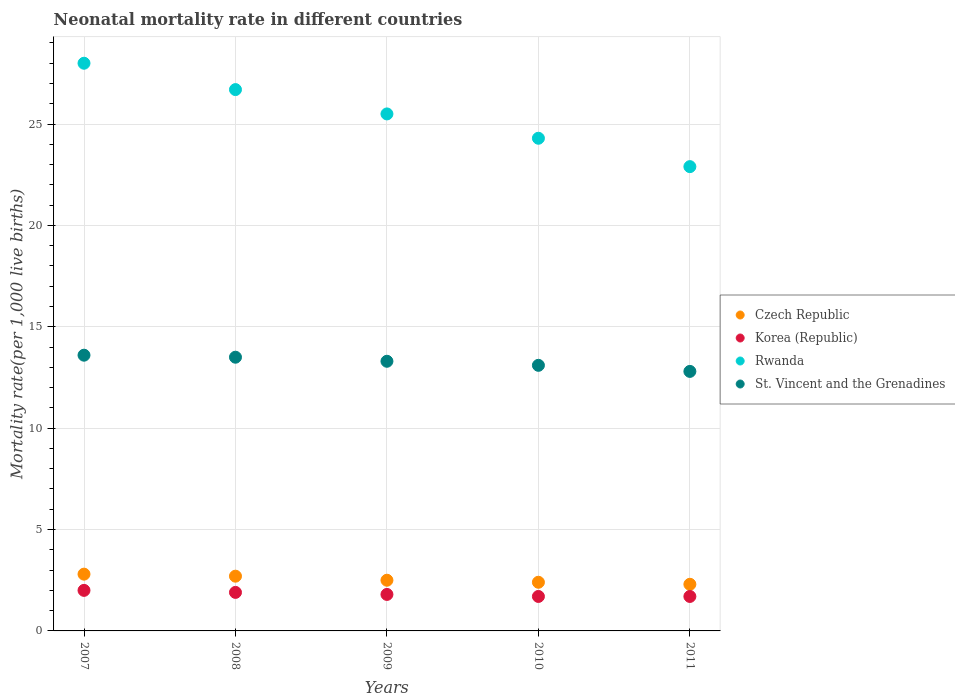How many different coloured dotlines are there?
Keep it short and to the point. 4. Across all years, what is the maximum neonatal mortality rate in Korea (Republic)?
Your response must be concise. 2. In which year was the neonatal mortality rate in St. Vincent and the Grenadines maximum?
Offer a very short reply. 2007. In which year was the neonatal mortality rate in Czech Republic minimum?
Offer a terse response. 2011. What is the total neonatal mortality rate in Czech Republic in the graph?
Provide a succinct answer. 12.7. What is the difference between the neonatal mortality rate in Rwanda in 2007 and that in 2010?
Your answer should be very brief. 3.7. What is the difference between the neonatal mortality rate in Czech Republic in 2009 and the neonatal mortality rate in Rwanda in 2007?
Give a very brief answer. -25.5. What is the average neonatal mortality rate in St. Vincent and the Grenadines per year?
Your response must be concise. 13.26. In how many years, is the neonatal mortality rate in Korea (Republic) greater than 23?
Make the answer very short. 0. What is the ratio of the neonatal mortality rate in Rwanda in 2008 to that in 2009?
Offer a very short reply. 1.05. Is the neonatal mortality rate in Korea (Republic) in 2009 less than that in 2010?
Provide a short and direct response. No. Is the difference between the neonatal mortality rate in Czech Republic in 2007 and 2008 greater than the difference between the neonatal mortality rate in Korea (Republic) in 2007 and 2008?
Your response must be concise. No. What is the difference between the highest and the second highest neonatal mortality rate in Korea (Republic)?
Give a very brief answer. 0.1. What is the difference between the highest and the lowest neonatal mortality rate in St. Vincent and the Grenadines?
Ensure brevity in your answer.  0.8. Is it the case that in every year, the sum of the neonatal mortality rate in Korea (Republic) and neonatal mortality rate in Rwanda  is greater than the sum of neonatal mortality rate in Czech Republic and neonatal mortality rate in St. Vincent and the Grenadines?
Provide a succinct answer. Yes. Is it the case that in every year, the sum of the neonatal mortality rate in Czech Republic and neonatal mortality rate in St. Vincent and the Grenadines  is greater than the neonatal mortality rate in Rwanda?
Ensure brevity in your answer.  No. Does the neonatal mortality rate in St. Vincent and the Grenadines monotonically increase over the years?
Make the answer very short. No. How many years are there in the graph?
Provide a short and direct response. 5. Does the graph contain grids?
Your answer should be compact. Yes. Where does the legend appear in the graph?
Your answer should be compact. Center right. What is the title of the graph?
Offer a very short reply. Neonatal mortality rate in different countries. What is the label or title of the Y-axis?
Offer a terse response. Mortality rate(per 1,0 live births). What is the Mortality rate(per 1,000 live births) in St. Vincent and the Grenadines in 2007?
Make the answer very short. 13.6. What is the Mortality rate(per 1,000 live births) of Korea (Republic) in 2008?
Ensure brevity in your answer.  1.9. What is the Mortality rate(per 1,000 live births) of Rwanda in 2008?
Keep it short and to the point. 26.7. What is the Mortality rate(per 1,000 live births) of St. Vincent and the Grenadines in 2008?
Provide a succinct answer. 13.5. What is the Mortality rate(per 1,000 live births) in Czech Republic in 2009?
Offer a terse response. 2.5. What is the Mortality rate(per 1,000 live births) of Rwanda in 2009?
Offer a terse response. 25.5. What is the Mortality rate(per 1,000 live births) in St. Vincent and the Grenadines in 2009?
Make the answer very short. 13.3. What is the Mortality rate(per 1,000 live births) of Czech Republic in 2010?
Provide a succinct answer. 2.4. What is the Mortality rate(per 1,000 live births) in Rwanda in 2010?
Keep it short and to the point. 24.3. What is the Mortality rate(per 1,000 live births) in St. Vincent and the Grenadines in 2010?
Make the answer very short. 13.1. What is the Mortality rate(per 1,000 live births) in Czech Republic in 2011?
Provide a short and direct response. 2.3. What is the Mortality rate(per 1,000 live births) of Korea (Republic) in 2011?
Your answer should be compact. 1.7. What is the Mortality rate(per 1,000 live births) of Rwanda in 2011?
Give a very brief answer. 22.9. Across all years, what is the maximum Mortality rate(per 1,000 live births) in Rwanda?
Provide a short and direct response. 28. Across all years, what is the minimum Mortality rate(per 1,000 live births) in Czech Republic?
Your response must be concise. 2.3. Across all years, what is the minimum Mortality rate(per 1,000 live births) of Korea (Republic)?
Your answer should be very brief. 1.7. Across all years, what is the minimum Mortality rate(per 1,000 live births) of Rwanda?
Keep it short and to the point. 22.9. Across all years, what is the minimum Mortality rate(per 1,000 live births) of St. Vincent and the Grenadines?
Give a very brief answer. 12.8. What is the total Mortality rate(per 1,000 live births) in Czech Republic in the graph?
Your answer should be very brief. 12.7. What is the total Mortality rate(per 1,000 live births) in Korea (Republic) in the graph?
Offer a terse response. 9.1. What is the total Mortality rate(per 1,000 live births) in Rwanda in the graph?
Your response must be concise. 127.4. What is the total Mortality rate(per 1,000 live births) of St. Vincent and the Grenadines in the graph?
Offer a very short reply. 66.3. What is the difference between the Mortality rate(per 1,000 live births) of Rwanda in 2007 and that in 2009?
Your response must be concise. 2.5. What is the difference between the Mortality rate(per 1,000 live births) of St. Vincent and the Grenadines in 2007 and that in 2009?
Keep it short and to the point. 0.3. What is the difference between the Mortality rate(per 1,000 live births) in Czech Republic in 2007 and that in 2010?
Your answer should be compact. 0.4. What is the difference between the Mortality rate(per 1,000 live births) in Czech Republic in 2007 and that in 2011?
Give a very brief answer. 0.5. What is the difference between the Mortality rate(per 1,000 live births) in St. Vincent and the Grenadines in 2007 and that in 2011?
Provide a short and direct response. 0.8. What is the difference between the Mortality rate(per 1,000 live births) in Czech Republic in 2008 and that in 2009?
Your answer should be very brief. 0.2. What is the difference between the Mortality rate(per 1,000 live births) of Korea (Republic) in 2008 and that in 2009?
Offer a terse response. 0.1. What is the difference between the Mortality rate(per 1,000 live births) in Rwanda in 2008 and that in 2009?
Your response must be concise. 1.2. What is the difference between the Mortality rate(per 1,000 live births) of St. Vincent and the Grenadines in 2008 and that in 2009?
Offer a terse response. 0.2. What is the difference between the Mortality rate(per 1,000 live births) in Korea (Republic) in 2008 and that in 2010?
Keep it short and to the point. 0.2. What is the difference between the Mortality rate(per 1,000 live births) in Rwanda in 2008 and that in 2010?
Your answer should be very brief. 2.4. What is the difference between the Mortality rate(per 1,000 live births) in St. Vincent and the Grenadines in 2008 and that in 2010?
Your answer should be very brief. 0.4. What is the difference between the Mortality rate(per 1,000 live births) of Czech Republic in 2008 and that in 2011?
Ensure brevity in your answer.  0.4. What is the difference between the Mortality rate(per 1,000 live births) of Korea (Republic) in 2008 and that in 2011?
Offer a terse response. 0.2. What is the difference between the Mortality rate(per 1,000 live births) of Rwanda in 2008 and that in 2011?
Make the answer very short. 3.8. What is the difference between the Mortality rate(per 1,000 live births) of St. Vincent and the Grenadines in 2008 and that in 2011?
Offer a terse response. 0.7. What is the difference between the Mortality rate(per 1,000 live births) of Czech Republic in 2009 and that in 2010?
Make the answer very short. 0.1. What is the difference between the Mortality rate(per 1,000 live births) of Korea (Republic) in 2009 and that in 2010?
Make the answer very short. 0.1. What is the difference between the Mortality rate(per 1,000 live births) of Czech Republic in 2009 and that in 2011?
Provide a short and direct response. 0.2. What is the difference between the Mortality rate(per 1,000 live births) of Korea (Republic) in 2009 and that in 2011?
Your answer should be compact. 0.1. What is the difference between the Mortality rate(per 1,000 live births) of Rwanda in 2009 and that in 2011?
Offer a very short reply. 2.6. What is the difference between the Mortality rate(per 1,000 live births) in Korea (Republic) in 2010 and that in 2011?
Offer a very short reply. 0. What is the difference between the Mortality rate(per 1,000 live births) of Rwanda in 2010 and that in 2011?
Give a very brief answer. 1.4. What is the difference between the Mortality rate(per 1,000 live births) in St. Vincent and the Grenadines in 2010 and that in 2011?
Your response must be concise. 0.3. What is the difference between the Mortality rate(per 1,000 live births) in Czech Republic in 2007 and the Mortality rate(per 1,000 live births) in Rwanda in 2008?
Ensure brevity in your answer.  -23.9. What is the difference between the Mortality rate(per 1,000 live births) in Czech Republic in 2007 and the Mortality rate(per 1,000 live births) in St. Vincent and the Grenadines in 2008?
Your response must be concise. -10.7. What is the difference between the Mortality rate(per 1,000 live births) in Korea (Republic) in 2007 and the Mortality rate(per 1,000 live births) in Rwanda in 2008?
Ensure brevity in your answer.  -24.7. What is the difference between the Mortality rate(per 1,000 live births) of Czech Republic in 2007 and the Mortality rate(per 1,000 live births) of Rwanda in 2009?
Your response must be concise. -22.7. What is the difference between the Mortality rate(per 1,000 live births) of Czech Republic in 2007 and the Mortality rate(per 1,000 live births) of St. Vincent and the Grenadines in 2009?
Provide a short and direct response. -10.5. What is the difference between the Mortality rate(per 1,000 live births) of Korea (Republic) in 2007 and the Mortality rate(per 1,000 live births) of Rwanda in 2009?
Offer a terse response. -23.5. What is the difference between the Mortality rate(per 1,000 live births) in Korea (Republic) in 2007 and the Mortality rate(per 1,000 live births) in St. Vincent and the Grenadines in 2009?
Give a very brief answer. -11.3. What is the difference between the Mortality rate(per 1,000 live births) in Czech Republic in 2007 and the Mortality rate(per 1,000 live births) in Rwanda in 2010?
Give a very brief answer. -21.5. What is the difference between the Mortality rate(per 1,000 live births) of Korea (Republic) in 2007 and the Mortality rate(per 1,000 live births) of Rwanda in 2010?
Provide a short and direct response. -22.3. What is the difference between the Mortality rate(per 1,000 live births) in Rwanda in 2007 and the Mortality rate(per 1,000 live births) in St. Vincent and the Grenadines in 2010?
Make the answer very short. 14.9. What is the difference between the Mortality rate(per 1,000 live births) of Czech Republic in 2007 and the Mortality rate(per 1,000 live births) of Rwanda in 2011?
Provide a succinct answer. -20.1. What is the difference between the Mortality rate(per 1,000 live births) in Korea (Republic) in 2007 and the Mortality rate(per 1,000 live births) in Rwanda in 2011?
Make the answer very short. -20.9. What is the difference between the Mortality rate(per 1,000 live births) in Korea (Republic) in 2007 and the Mortality rate(per 1,000 live births) in St. Vincent and the Grenadines in 2011?
Offer a terse response. -10.8. What is the difference between the Mortality rate(per 1,000 live births) of Czech Republic in 2008 and the Mortality rate(per 1,000 live births) of Korea (Republic) in 2009?
Your response must be concise. 0.9. What is the difference between the Mortality rate(per 1,000 live births) of Czech Republic in 2008 and the Mortality rate(per 1,000 live births) of Rwanda in 2009?
Make the answer very short. -22.8. What is the difference between the Mortality rate(per 1,000 live births) in Czech Republic in 2008 and the Mortality rate(per 1,000 live births) in St. Vincent and the Grenadines in 2009?
Give a very brief answer. -10.6. What is the difference between the Mortality rate(per 1,000 live births) of Korea (Republic) in 2008 and the Mortality rate(per 1,000 live births) of Rwanda in 2009?
Provide a short and direct response. -23.6. What is the difference between the Mortality rate(per 1,000 live births) in Czech Republic in 2008 and the Mortality rate(per 1,000 live births) in Rwanda in 2010?
Give a very brief answer. -21.6. What is the difference between the Mortality rate(per 1,000 live births) of Czech Republic in 2008 and the Mortality rate(per 1,000 live births) of St. Vincent and the Grenadines in 2010?
Your answer should be compact. -10.4. What is the difference between the Mortality rate(per 1,000 live births) of Korea (Republic) in 2008 and the Mortality rate(per 1,000 live births) of Rwanda in 2010?
Give a very brief answer. -22.4. What is the difference between the Mortality rate(per 1,000 live births) in Rwanda in 2008 and the Mortality rate(per 1,000 live births) in St. Vincent and the Grenadines in 2010?
Keep it short and to the point. 13.6. What is the difference between the Mortality rate(per 1,000 live births) in Czech Republic in 2008 and the Mortality rate(per 1,000 live births) in Rwanda in 2011?
Provide a short and direct response. -20.2. What is the difference between the Mortality rate(per 1,000 live births) in Czech Republic in 2008 and the Mortality rate(per 1,000 live births) in St. Vincent and the Grenadines in 2011?
Your response must be concise. -10.1. What is the difference between the Mortality rate(per 1,000 live births) of Korea (Republic) in 2008 and the Mortality rate(per 1,000 live births) of Rwanda in 2011?
Provide a succinct answer. -21. What is the difference between the Mortality rate(per 1,000 live births) in Korea (Republic) in 2008 and the Mortality rate(per 1,000 live births) in St. Vincent and the Grenadines in 2011?
Offer a terse response. -10.9. What is the difference between the Mortality rate(per 1,000 live births) in Czech Republic in 2009 and the Mortality rate(per 1,000 live births) in Korea (Republic) in 2010?
Make the answer very short. 0.8. What is the difference between the Mortality rate(per 1,000 live births) of Czech Republic in 2009 and the Mortality rate(per 1,000 live births) of Rwanda in 2010?
Your response must be concise. -21.8. What is the difference between the Mortality rate(per 1,000 live births) of Korea (Republic) in 2009 and the Mortality rate(per 1,000 live births) of Rwanda in 2010?
Ensure brevity in your answer.  -22.5. What is the difference between the Mortality rate(per 1,000 live births) in Czech Republic in 2009 and the Mortality rate(per 1,000 live births) in Rwanda in 2011?
Make the answer very short. -20.4. What is the difference between the Mortality rate(per 1,000 live births) of Korea (Republic) in 2009 and the Mortality rate(per 1,000 live births) of Rwanda in 2011?
Give a very brief answer. -21.1. What is the difference between the Mortality rate(per 1,000 live births) of Korea (Republic) in 2009 and the Mortality rate(per 1,000 live births) of St. Vincent and the Grenadines in 2011?
Provide a short and direct response. -11. What is the difference between the Mortality rate(per 1,000 live births) of Czech Republic in 2010 and the Mortality rate(per 1,000 live births) of Rwanda in 2011?
Make the answer very short. -20.5. What is the difference between the Mortality rate(per 1,000 live births) in Korea (Republic) in 2010 and the Mortality rate(per 1,000 live births) in Rwanda in 2011?
Provide a short and direct response. -21.2. What is the average Mortality rate(per 1,000 live births) of Czech Republic per year?
Offer a very short reply. 2.54. What is the average Mortality rate(per 1,000 live births) in Korea (Republic) per year?
Offer a terse response. 1.82. What is the average Mortality rate(per 1,000 live births) in Rwanda per year?
Your response must be concise. 25.48. What is the average Mortality rate(per 1,000 live births) in St. Vincent and the Grenadines per year?
Your response must be concise. 13.26. In the year 2007, what is the difference between the Mortality rate(per 1,000 live births) of Czech Republic and Mortality rate(per 1,000 live births) of Rwanda?
Provide a short and direct response. -25.2. In the year 2007, what is the difference between the Mortality rate(per 1,000 live births) of Czech Republic and Mortality rate(per 1,000 live births) of St. Vincent and the Grenadines?
Make the answer very short. -10.8. In the year 2008, what is the difference between the Mortality rate(per 1,000 live births) of Czech Republic and Mortality rate(per 1,000 live births) of St. Vincent and the Grenadines?
Give a very brief answer. -10.8. In the year 2008, what is the difference between the Mortality rate(per 1,000 live births) in Korea (Republic) and Mortality rate(per 1,000 live births) in Rwanda?
Ensure brevity in your answer.  -24.8. In the year 2009, what is the difference between the Mortality rate(per 1,000 live births) in Czech Republic and Mortality rate(per 1,000 live births) in Korea (Republic)?
Your answer should be compact. 0.7. In the year 2009, what is the difference between the Mortality rate(per 1,000 live births) in Czech Republic and Mortality rate(per 1,000 live births) in St. Vincent and the Grenadines?
Keep it short and to the point. -10.8. In the year 2009, what is the difference between the Mortality rate(per 1,000 live births) in Korea (Republic) and Mortality rate(per 1,000 live births) in Rwanda?
Offer a terse response. -23.7. In the year 2010, what is the difference between the Mortality rate(per 1,000 live births) of Czech Republic and Mortality rate(per 1,000 live births) of Rwanda?
Offer a terse response. -21.9. In the year 2010, what is the difference between the Mortality rate(per 1,000 live births) of Czech Republic and Mortality rate(per 1,000 live births) of St. Vincent and the Grenadines?
Provide a short and direct response. -10.7. In the year 2010, what is the difference between the Mortality rate(per 1,000 live births) of Korea (Republic) and Mortality rate(per 1,000 live births) of Rwanda?
Provide a short and direct response. -22.6. In the year 2011, what is the difference between the Mortality rate(per 1,000 live births) of Czech Republic and Mortality rate(per 1,000 live births) of Rwanda?
Ensure brevity in your answer.  -20.6. In the year 2011, what is the difference between the Mortality rate(per 1,000 live births) in Korea (Republic) and Mortality rate(per 1,000 live births) in Rwanda?
Offer a terse response. -21.2. In the year 2011, what is the difference between the Mortality rate(per 1,000 live births) of Korea (Republic) and Mortality rate(per 1,000 live births) of St. Vincent and the Grenadines?
Your response must be concise. -11.1. What is the ratio of the Mortality rate(per 1,000 live births) of Czech Republic in 2007 to that in 2008?
Offer a very short reply. 1.04. What is the ratio of the Mortality rate(per 1,000 live births) in Korea (Republic) in 2007 to that in 2008?
Your answer should be compact. 1.05. What is the ratio of the Mortality rate(per 1,000 live births) of Rwanda in 2007 to that in 2008?
Give a very brief answer. 1.05. What is the ratio of the Mortality rate(per 1,000 live births) in St. Vincent and the Grenadines in 2007 to that in 2008?
Your answer should be very brief. 1.01. What is the ratio of the Mortality rate(per 1,000 live births) of Czech Republic in 2007 to that in 2009?
Ensure brevity in your answer.  1.12. What is the ratio of the Mortality rate(per 1,000 live births) in Korea (Republic) in 2007 to that in 2009?
Make the answer very short. 1.11. What is the ratio of the Mortality rate(per 1,000 live births) in Rwanda in 2007 to that in 2009?
Give a very brief answer. 1.1. What is the ratio of the Mortality rate(per 1,000 live births) in St. Vincent and the Grenadines in 2007 to that in 2009?
Your response must be concise. 1.02. What is the ratio of the Mortality rate(per 1,000 live births) of Czech Republic in 2007 to that in 2010?
Your answer should be compact. 1.17. What is the ratio of the Mortality rate(per 1,000 live births) of Korea (Republic) in 2007 to that in 2010?
Offer a very short reply. 1.18. What is the ratio of the Mortality rate(per 1,000 live births) in Rwanda in 2007 to that in 2010?
Make the answer very short. 1.15. What is the ratio of the Mortality rate(per 1,000 live births) of St. Vincent and the Grenadines in 2007 to that in 2010?
Ensure brevity in your answer.  1.04. What is the ratio of the Mortality rate(per 1,000 live births) of Czech Republic in 2007 to that in 2011?
Provide a succinct answer. 1.22. What is the ratio of the Mortality rate(per 1,000 live births) of Korea (Republic) in 2007 to that in 2011?
Your response must be concise. 1.18. What is the ratio of the Mortality rate(per 1,000 live births) in Rwanda in 2007 to that in 2011?
Provide a short and direct response. 1.22. What is the ratio of the Mortality rate(per 1,000 live births) of St. Vincent and the Grenadines in 2007 to that in 2011?
Keep it short and to the point. 1.06. What is the ratio of the Mortality rate(per 1,000 live births) in Czech Republic in 2008 to that in 2009?
Ensure brevity in your answer.  1.08. What is the ratio of the Mortality rate(per 1,000 live births) of Korea (Republic) in 2008 to that in 2009?
Ensure brevity in your answer.  1.06. What is the ratio of the Mortality rate(per 1,000 live births) in Rwanda in 2008 to that in 2009?
Offer a terse response. 1.05. What is the ratio of the Mortality rate(per 1,000 live births) in St. Vincent and the Grenadines in 2008 to that in 2009?
Provide a succinct answer. 1.01. What is the ratio of the Mortality rate(per 1,000 live births) of Korea (Republic) in 2008 to that in 2010?
Your response must be concise. 1.12. What is the ratio of the Mortality rate(per 1,000 live births) of Rwanda in 2008 to that in 2010?
Your response must be concise. 1.1. What is the ratio of the Mortality rate(per 1,000 live births) of St. Vincent and the Grenadines in 2008 to that in 2010?
Provide a succinct answer. 1.03. What is the ratio of the Mortality rate(per 1,000 live births) of Czech Republic in 2008 to that in 2011?
Provide a short and direct response. 1.17. What is the ratio of the Mortality rate(per 1,000 live births) in Korea (Republic) in 2008 to that in 2011?
Provide a short and direct response. 1.12. What is the ratio of the Mortality rate(per 1,000 live births) in Rwanda in 2008 to that in 2011?
Keep it short and to the point. 1.17. What is the ratio of the Mortality rate(per 1,000 live births) of St. Vincent and the Grenadines in 2008 to that in 2011?
Make the answer very short. 1.05. What is the ratio of the Mortality rate(per 1,000 live births) of Czech Republic in 2009 to that in 2010?
Ensure brevity in your answer.  1.04. What is the ratio of the Mortality rate(per 1,000 live births) of Korea (Republic) in 2009 to that in 2010?
Provide a short and direct response. 1.06. What is the ratio of the Mortality rate(per 1,000 live births) of Rwanda in 2009 to that in 2010?
Offer a very short reply. 1.05. What is the ratio of the Mortality rate(per 1,000 live births) in St. Vincent and the Grenadines in 2009 to that in 2010?
Your answer should be compact. 1.02. What is the ratio of the Mortality rate(per 1,000 live births) in Czech Republic in 2009 to that in 2011?
Offer a terse response. 1.09. What is the ratio of the Mortality rate(per 1,000 live births) of Korea (Republic) in 2009 to that in 2011?
Your answer should be compact. 1.06. What is the ratio of the Mortality rate(per 1,000 live births) of Rwanda in 2009 to that in 2011?
Your answer should be very brief. 1.11. What is the ratio of the Mortality rate(per 1,000 live births) in St. Vincent and the Grenadines in 2009 to that in 2011?
Your response must be concise. 1.04. What is the ratio of the Mortality rate(per 1,000 live births) of Czech Republic in 2010 to that in 2011?
Keep it short and to the point. 1.04. What is the ratio of the Mortality rate(per 1,000 live births) in Korea (Republic) in 2010 to that in 2011?
Ensure brevity in your answer.  1. What is the ratio of the Mortality rate(per 1,000 live births) of Rwanda in 2010 to that in 2011?
Your answer should be compact. 1.06. What is the ratio of the Mortality rate(per 1,000 live births) in St. Vincent and the Grenadines in 2010 to that in 2011?
Provide a succinct answer. 1.02. What is the difference between the highest and the second highest Mortality rate(per 1,000 live births) in Korea (Republic)?
Offer a very short reply. 0.1. What is the difference between the highest and the lowest Mortality rate(per 1,000 live births) of Rwanda?
Provide a succinct answer. 5.1. What is the difference between the highest and the lowest Mortality rate(per 1,000 live births) in St. Vincent and the Grenadines?
Your answer should be very brief. 0.8. 